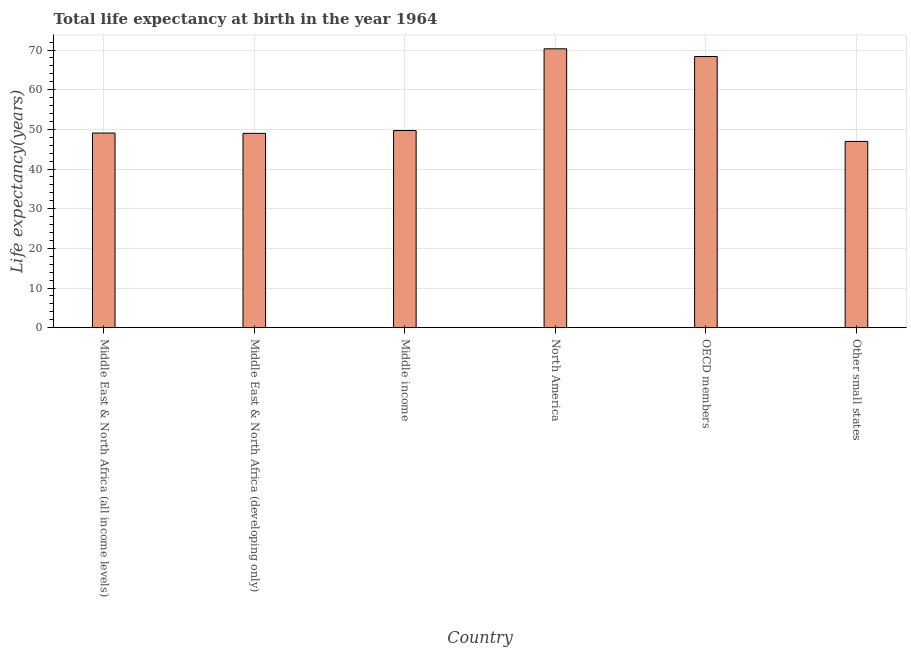What is the title of the graph?
Provide a succinct answer. Total life expectancy at birth in the year 1964. What is the label or title of the Y-axis?
Your answer should be compact. Life expectancy(years). What is the life expectancy at birth in OECD members?
Provide a short and direct response. 68.37. Across all countries, what is the maximum life expectancy at birth?
Keep it short and to the point. 70.31. Across all countries, what is the minimum life expectancy at birth?
Give a very brief answer. 46.96. In which country was the life expectancy at birth minimum?
Your answer should be compact. Other small states. What is the sum of the life expectancy at birth?
Your answer should be compact. 333.42. What is the difference between the life expectancy at birth in Middle East & North Africa (all income levels) and Middle East & North Africa (developing only)?
Your answer should be very brief. 0.07. What is the average life expectancy at birth per country?
Offer a terse response. 55.57. What is the median life expectancy at birth?
Your response must be concise. 49.39. What is the ratio of the life expectancy at birth in Middle East & North Africa (all income levels) to that in OECD members?
Make the answer very short. 0.72. What is the difference between the highest and the second highest life expectancy at birth?
Offer a terse response. 1.94. Is the sum of the life expectancy at birth in North America and OECD members greater than the maximum life expectancy at birth across all countries?
Offer a terse response. Yes. What is the difference between the highest and the lowest life expectancy at birth?
Offer a very short reply. 23.35. What is the Life expectancy(years) in Middle East & North Africa (all income levels)?
Provide a succinct answer. 49.07. What is the Life expectancy(years) in Middle East & North Africa (developing only)?
Offer a very short reply. 49. What is the Life expectancy(years) in Middle income?
Make the answer very short. 49.7. What is the Life expectancy(years) of North America?
Your answer should be very brief. 70.31. What is the Life expectancy(years) in OECD members?
Keep it short and to the point. 68.37. What is the Life expectancy(years) of Other small states?
Your response must be concise. 46.96. What is the difference between the Life expectancy(years) in Middle East & North Africa (all income levels) and Middle East & North Africa (developing only)?
Give a very brief answer. 0.07. What is the difference between the Life expectancy(years) in Middle East & North Africa (all income levels) and Middle income?
Your answer should be compact. -0.63. What is the difference between the Life expectancy(years) in Middle East & North Africa (all income levels) and North America?
Keep it short and to the point. -21.24. What is the difference between the Life expectancy(years) in Middle East & North Africa (all income levels) and OECD members?
Your response must be concise. -19.3. What is the difference between the Life expectancy(years) in Middle East & North Africa (all income levels) and Other small states?
Provide a succinct answer. 2.11. What is the difference between the Life expectancy(years) in Middle East & North Africa (developing only) and Middle income?
Provide a succinct answer. -0.71. What is the difference between the Life expectancy(years) in Middle East & North Africa (developing only) and North America?
Provide a succinct answer. -21.32. What is the difference between the Life expectancy(years) in Middle East & North Africa (developing only) and OECD members?
Offer a terse response. -19.38. What is the difference between the Life expectancy(years) in Middle East & North Africa (developing only) and Other small states?
Provide a succinct answer. 2.03. What is the difference between the Life expectancy(years) in Middle income and North America?
Provide a succinct answer. -20.61. What is the difference between the Life expectancy(years) in Middle income and OECD members?
Keep it short and to the point. -18.67. What is the difference between the Life expectancy(years) in Middle income and Other small states?
Keep it short and to the point. 2.74. What is the difference between the Life expectancy(years) in North America and OECD members?
Your answer should be compact. 1.94. What is the difference between the Life expectancy(years) in North America and Other small states?
Offer a very short reply. 23.35. What is the difference between the Life expectancy(years) in OECD members and Other small states?
Offer a terse response. 21.41. What is the ratio of the Life expectancy(years) in Middle East & North Africa (all income levels) to that in North America?
Offer a very short reply. 0.7. What is the ratio of the Life expectancy(years) in Middle East & North Africa (all income levels) to that in OECD members?
Give a very brief answer. 0.72. What is the ratio of the Life expectancy(years) in Middle East & North Africa (all income levels) to that in Other small states?
Offer a very short reply. 1.04. What is the ratio of the Life expectancy(years) in Middle East & North Africa (developing only) to that in North America?
Ensure brevity in your answer.  0.7. What is the ratio of the Life expectancy(years) in Middle East & North Africa (developing only) to that in OECD members?
Ensure brevity in your answer.  0.72. What is the ratio of the Life expectancy(years) in Middle East & North Africa (developing only) to that in Other small states?
Give a very brief answer. 1.04. What is the ratio of the Life expectancy(years) in Middle income to that in North America?
Ensure brevity in your answer.  0.71. What is the ratio of the Life expectancy(years) in Middle income to that in OECD members?
Your answer should be compact. 0.73. What is the ratio of the Life expectancy(years) in Middle income to that in Other small states?
Your answer should be very brief. 1.06. What is the ratio of the Life expectancy(years) in North America to that in OECD members?
Keep it short and to the point. 1.03. What is the ratio of the Life expectancy(years) in North America to that in Other small states?
Provide a succinct answer. 1.5. What is the ratio of the Life expectancy(years) in OECD members to that in Other small states?
Ensure brevity in your answer.  1.46. 